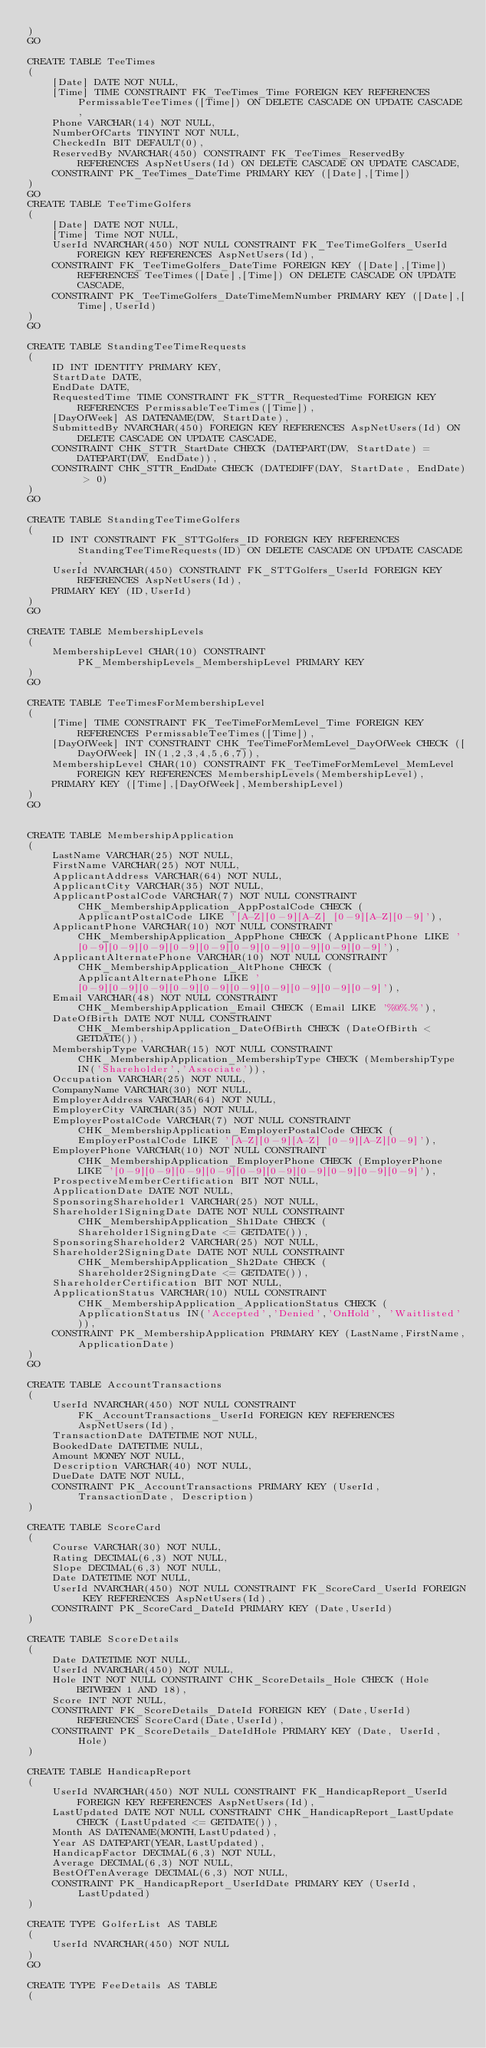<code> <loc_0><loc_0><loc_500><loc_500><_SQL_>)
GO

CREATE TABLE TeeTimes
(
	[Date] DATE NOT NULL,
	[Time] TIME CONSTRAINT FK_TeeTimes_Time FOREIGN KEY REFERENCES PermissableTeeTimes([Time]) ON DELETE CASCADE ON UPDATE CASCADE,
	Phone VARCHAR(14) NOT NULL,
	NumberOfCarts TINYINT NOT NULL,
	CheckedIn BIT DEFAULT(0),
	ReservedBy NVARCHAR(450) CONSTRAINT FK_TeeTimes_ReservedBy REFERENCES AspNetUsers(Id) ON DELETE CASCADE ON UPDATE CASCADE,
	CONSTRAINT PK_TeeTimes_DateTime PRIMARY KEY ([Date],[Time])
)
GO
CREATE TABLE TeeTimeGolfers
(
	[Date] DATE NOT NULL,
	[Time] Time NOT NULL,
	UserId NVARCHAR(450) NOT NULL CONSTRAINT FK_TeeTimeGolfers_UserId FOREIGN KEY REFERENCES AspNetUsers(Id),
	CONSTRAINT FK_TeeTimeGolfers_DateTime FOREIGN KEY ([Date],[Time]) REFERENCES TeeTimes([Date],[Time]) ON DELETE CASCADE ON UPDATE CASCADE,
	CONSTRAINT PK_TeeTimeGolfers_DateTimeMemNumber PRIMARY KEY ([Date],[Time],UserId)
)
GO

CREATE TABLE StandingTeeTimeRequests
(
	ID INT IDENTITY PRIMARY KEY,
	StartDate DATE,
	EndDate DATE,
	RequestedTime TIME CONSTRAINT FK_STTR_RequestedTime FOREIGN KEY REFERENCES PermissableTeeTimes([Time]),
	[DayOfWeek] AS DATENAME(DW, StartDate),
	SubmittedBy NVARCHAR(450) FOREIGN KEY REFERENCES AspNetUsers(Id) ON DELETE CASCADE ON UPDATE CASCADE,
	CONSTRAINT CHK_STTR_StartDate CHECK (DATEPART(DW, StartDate) = DATEPART(DW, EndDate)),
	CONSTRAINT CHK_STTR_EndDate CHECK (DATEDIFF(DAY, StartDate, EndDate) > 0)
)
GO

CREATE TABLE StandingTeeTimeGolfers
(
	ID INT CONSTRAINT FK_STTGolfers_ID FOREIGN KEY REFERENCES StandingTeeTimeRequests(ID) ON DELETE CASCADE ON UPDATE CASCADE,
	UserId NVARCHAR(450) CONSTRAINT FK_STTGolfers_UserId FOREIGN KEY REFERENCES AspNetUsers(Id),
	PRIMARY KEY (ID,UserId)
)
GO

CREATE TABLE MembershipLevels
(
	MembershipLevel CHAR(10) CONSTRAINT PK_MembershipLevels_MembershipLevel PRIMARY KEY
)
GO

CREATE TABLE TeeTimesForMembershipLevel
(
	[Time] TIME CONSTRAINT FK_TeeTimeForMemLevel_Time FOREIGN KEY REFERENCES PermissableTeeTimes([Time]),
	[DayOfWeek] INT CONSTRAINT CHK_TeeTimeForMemLevel_DayOfWeek CHECK ([DayOfWeek] IN(1,2,3,4,5,6,7)),
	MembershipLevel CHAR(10) CONSTRAINT FK_TeeTimeForMemLevel_MemLevel FOREIGN KEY REFERENCES MembershipLevels(MembershipLevel),
	PRIMARY KEY ([Time],[DayOfWeek],MembershipLevel)
)
GO


CREATE TABLE MembershipApplication
(
	LastName VARCHAR(25) NOT NULL,
	FirstName VARCHAR(25) NOT NULL,
	ApplicantAddress VARCHAR(64) NOT NULL,
	ApplicantCity VARCHAR(35) NOT NULL,
	ApplicantPostalCode VARCHAR(7) NOT NULL CONSTRAINT CHK_MembershipApplication_AppPostalCode CHECK (ApplicantPostalCode LIKE '[A-Z][0-9][A-Z] [0-9][A-Z][0-9]'),
	ApplicantPhone VARCHAR(10) NOT NULL CONSTRAINT CHK_MembershipApplication_AppPhone CHECK (ApplicantPhone LIKE '[0-9][0-9][0-9][0-9][0-9][0-9][0-9][0-9][0-9][0-9]'),
	ApplicantAlternatePhone VARCHAR(10) NOT NULL CONSTRAINT CHK_MembershipApplication_AltPhone CHECK (ApplicantAlternatePhone LIKE '[0-9][0-9][0-9][0-9][0-9][0-9][0-9][0-9][0-9][0-9]'),
	Email VARCHAR(48) NOT NULL CONSTRAINT CHK_MembershipApplication_Email CHECK (Email LIKE '%@%.%'),
	DateOfBirth DATE NOT NULL CONSTRAINT CHK_MembershipApplication_DateOfBirth CHECK (DateOfBirth < GETDATE()),
	MembershipType VARCHAR(15) NOT NULL CONSTRAINT CHK_MembershipApplication_MembershipType CHECK (MembershipType IN('Shareholder','Associate')),
	Occupation VARCHAR(25) NOT NULL,
	CompanyName VARCHAR(30) NOT NULL,
	EmployerAddress VARCHAR(64) NOT NULL,
	EmployerCity VARCHAR(35) NOT NULL,
	EmployerPostalCode VARCHAR(7) NOT NULL CONSTRAINT CHK_MembershipApplication_EmployerPostalCode CHECK (EmployerPostalCode LIKE '[A-Z][0-9][A-Z] [0-9][A-Z][0-9]'),
	EmployerPhone VARCHAR(10) NOT NULL CONSTRAINT CHK_MembershipApplication_EmployerPhone CHECK (EmployerPhone LIKE '[0-9][0-9][0-9][0-9][0-9][0-9][0-9][0-9][0-9][0-9]'),
	ProspectiveMemberCertification BIT NOT NULL,
	ApplicationDate DATE NOT NULL,
	SponsoringShareholder1 VARCHAR(25) NOT NULL,
	Shareholder1SigningDate DATE NOT NULL CONSTRAINT CHK_MembershipApplication_Sh1Date CHECK (Shareholder1SigningDate <= GETDATE()),
	SponsoringShareholder2 VARCHAR(25) NOT NULL,
	Shareholder2SigningDate DATE NOT NULL CONSTRAINT CHK_MembershipApplication_Sh2Date CHECK (Shareholder2SigningDate <= GETDATE()),
	ShareholderCertification BIT NOT NULL,
	ApplicationStatus VARCHAR(10) NULL CONSTRAINT CHK_MembershipApplication_ApplicationStatus CHECK (ApplicationStatus IN('Accepted','Denied','OnHold', 'Waitlisted')),
	CONSTRAINT PK_MembershipApplication PRIMARY KEY (LastName,FirstName,ApplicationDate)
)
GO

CREATE TABLE AccountTransactions
(
	UserId NVARCHAR(450) NOT NULL CONSTRAINT FK_AccountTransactions_UserId FOREIGN KEY REFERENCES AspNetUsers(Id),
	TransactionDate DATETIME NOT NULL,
	BookedDate DATETIME NULL,
	Amount MONEY NOT NULL,
	Description VARCHAR(40) NOT NULL,
	DueDate DATE NOT NULL,
	CONSTRAINT PK_AccountTransactions PRIMARY KEY (UserId, TransactionDate, Description)
)

CREATE TABLE ScoreCard
(
	Course VARCHAR(30) NOT NULL,
	Rating DECIMAL(6,3) NOT NULL,
	Slope DECIMAL(6,3) NOT NULL,
	Date DATETIME NOT NULL,
	UserId NVARCHAR(450) NOT NULL CONSTRAINT FK_ScoreCard_UserId FOREIGN KEY REFERENCES AspNetUsers(Id),
	CONSTRAINT PK_ScoreCard_DateId PRIMARY KEY (Date,UserId)
)

CREATE TABLE ScoreDetails
(
	Date DATETIME NOT NULL,
	UserId NVARCHAR(450) NOT NULL,
	Hole INT NOT NULL CONSTRAINT CHK_ScoreDetails_Hole CHECK (Hole BETWEEN 1 AND 18),
	Score INT NOT NULL,
	CONSTRAINT FK_ScoreDetails_DateId FOREIGN KEY (Date,UserId) REFERENCES ScoreCard(Date,UserId),
	CONSTRAINT PK_ScoreDetails_DateIdHole PRIMARY KEY (Date, UserId, Hole)
)

CREATE TABLE HandicapReport
(
	UserId NVARCHAR(450) NOT NULL CONSTRAINT FK_HandicapReport_UserId FOREIGN KEY REFERENCES AspNetUsers(Id),
	LastUpdated DATE NOT NULL CONSTRAINT CHK_HandicapReport_LastUpdate CHECK (LastUpdated <= GETDATE()),
	Month AS DATENAME(MONTH,LastUpdated),
	Year AS DATEPART(YEAR,LastUpdated),
	HandicapFactor DECIMAL(6,3) NOT NULL,
	Average DECIMAL(6,3) NOT NULL,
	BestOfTenAverage DECIMAL(6,3) NOT NULL,
	CONSTRAINT PK_HandicapReport_UserIdDate PRIMARY KEY (UserId, LastUpdated)
)

CREATE TYPE GolferList AS TABLE
(
	UserId NVARCHAR(450) NOT NULL
)
GO

CREATE TYPE FeeDetails AS TABLE
(</code> 